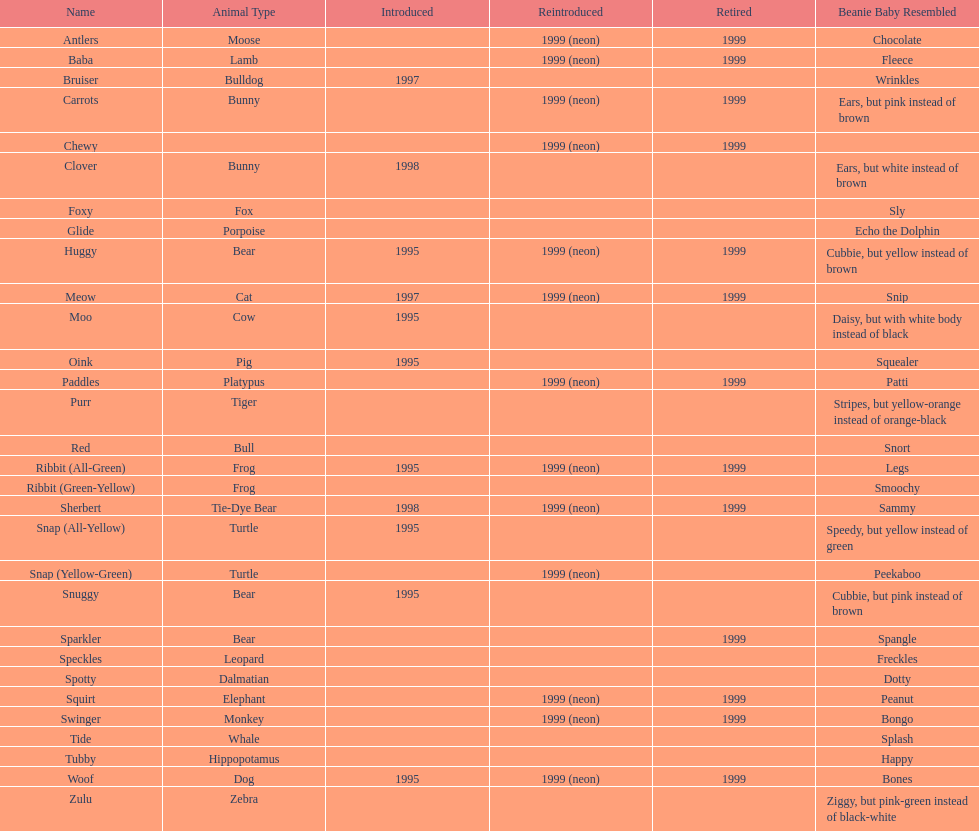How long was woof the dog sold before it was retired? 4 years. 